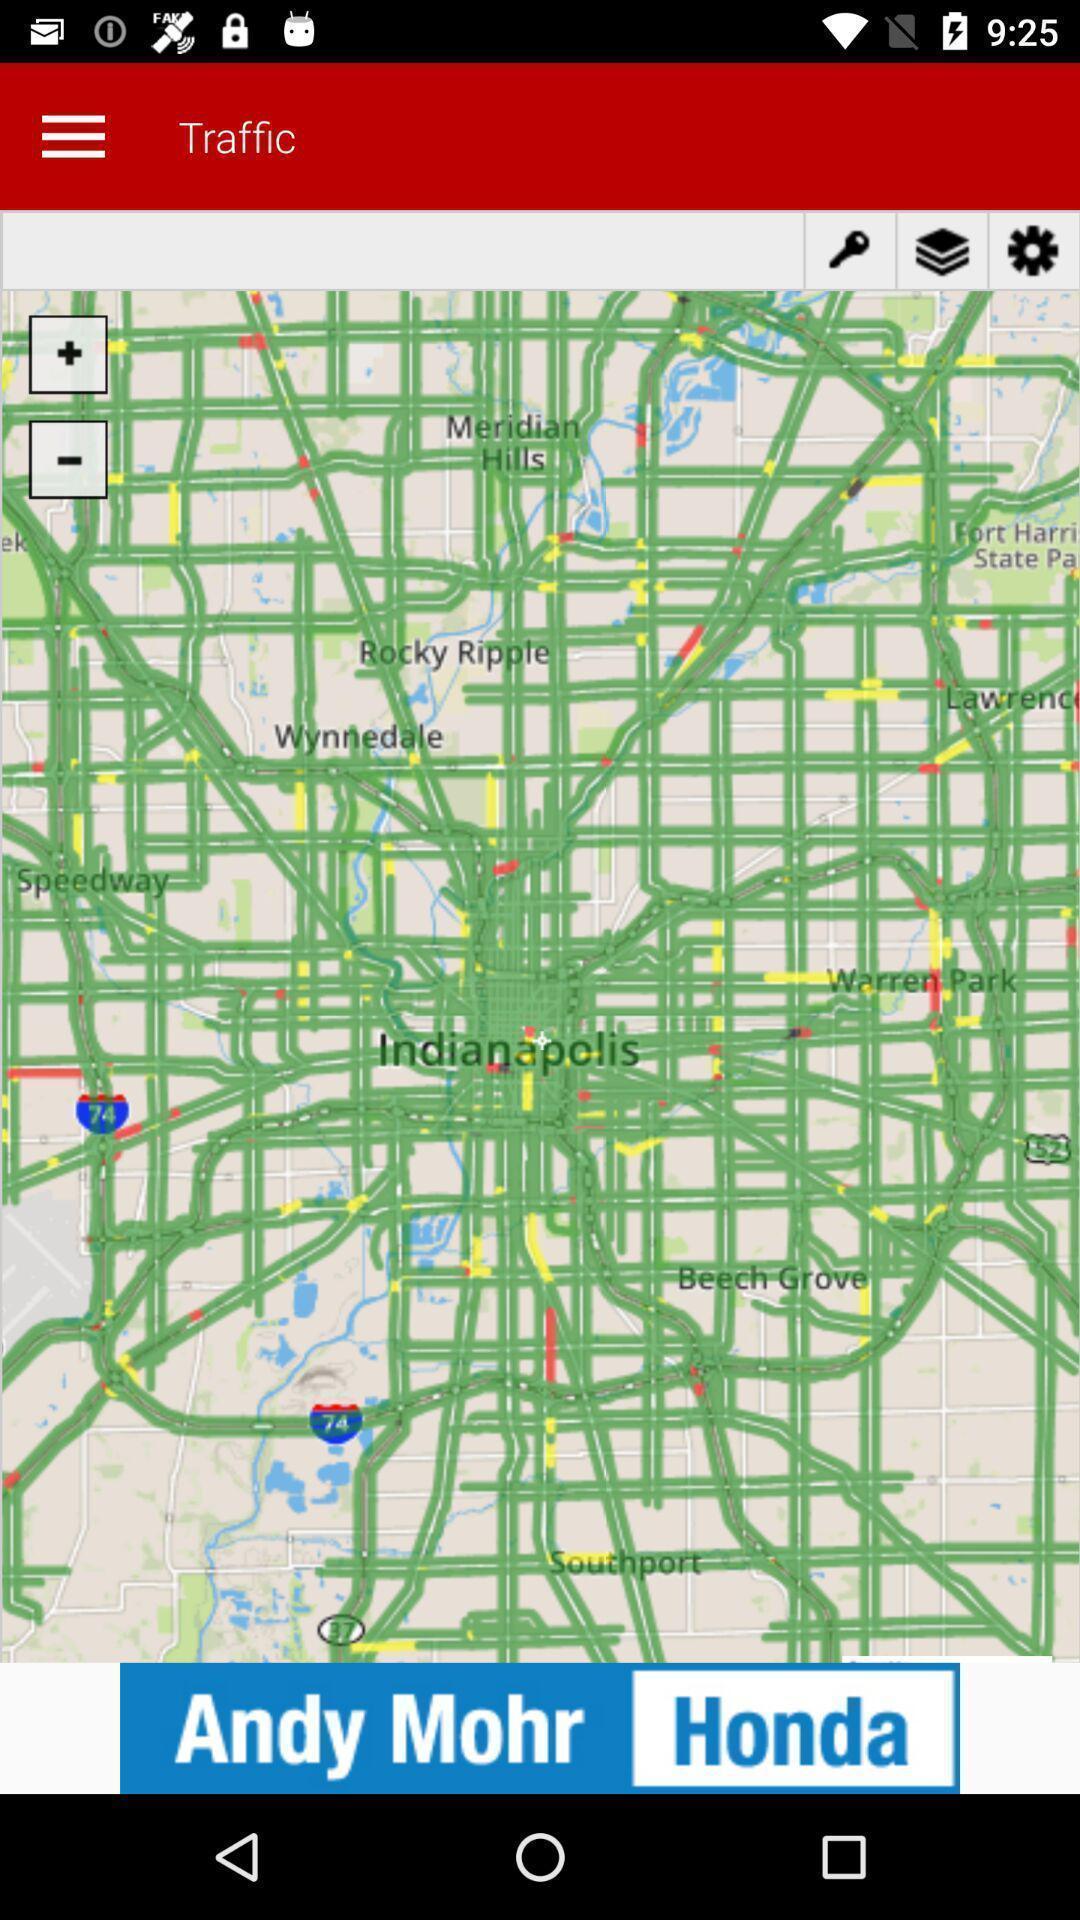Tell me about the visual elements in this screen capture. Page showing information from a traffic app. 